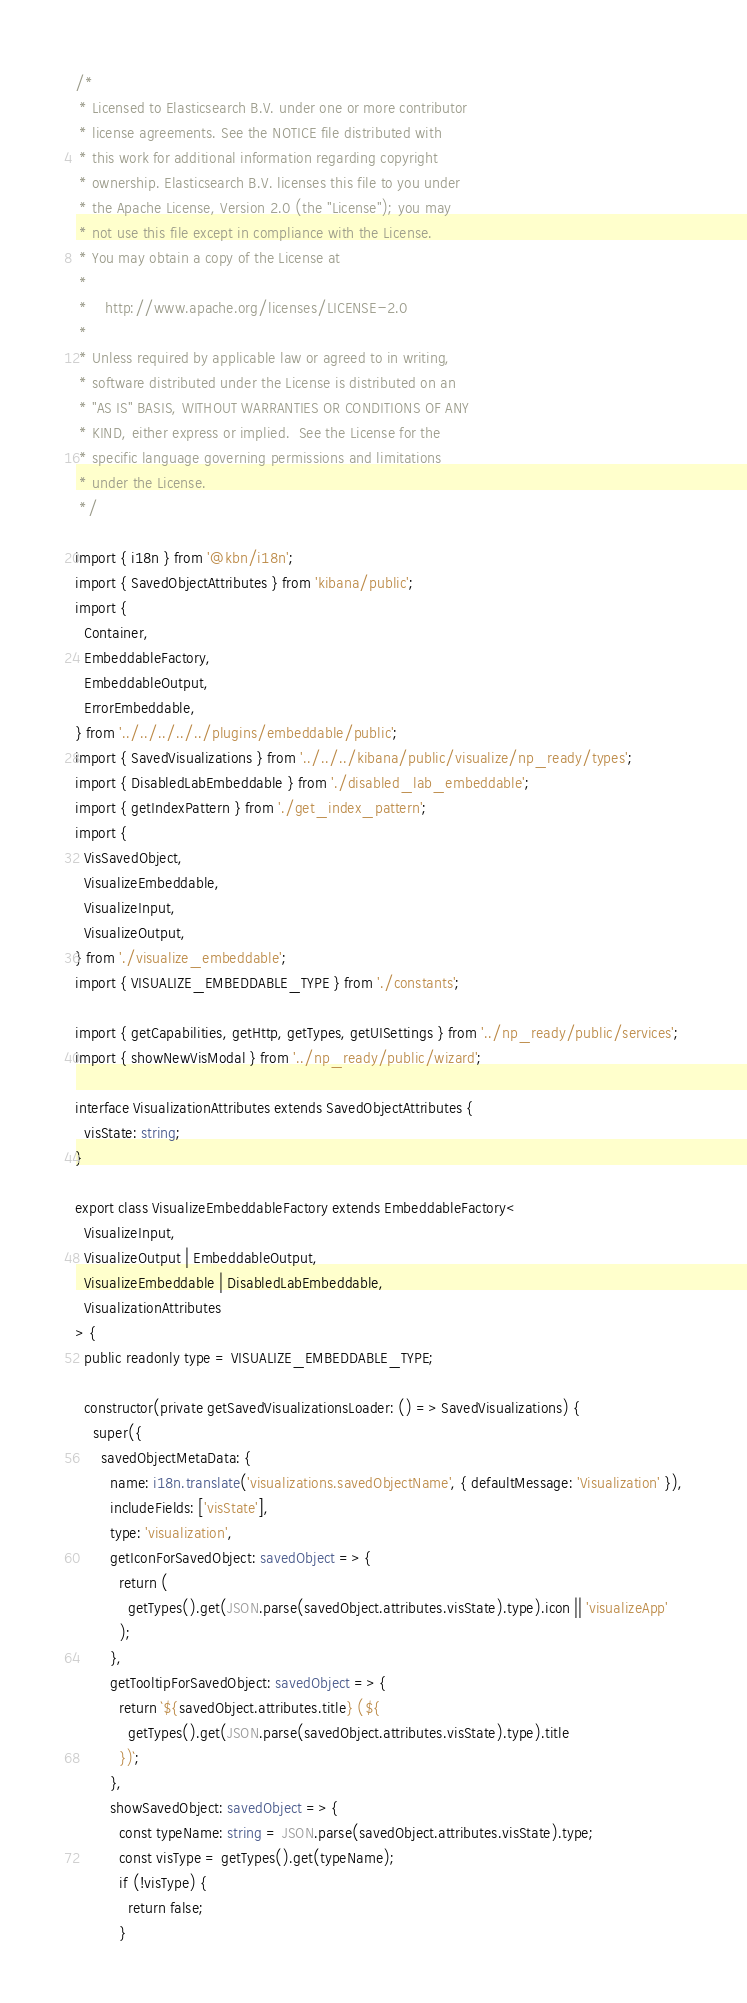<code> <loc_0><loc_0><loc_500><loc_500><_TypeScript_>/*
 * Licensed to Elasticsearch B.V. under one or more contributor
 * license agreements. See the NOTICE file distributed with
 * this work for additional information regarding copyright
 * ownership. Elasticsearch B.V. licenses this file to you under
 * the Apache License, Version 2.0 (the "License"); you may
 * not use this file except in compliance with the License.
 * You may obtain a copy of the License at
 *
 *    http://www.apache.org/licenses/LICENSE-2.0
 *
 * Unless required by applicable law or agreed to in writing,
 * software distributed under the License is distributed on an
 * "AS IS" BASIS, WITHOUT WARRANTIES OR CONDITIONS OF ANY
 * KIND, either express or implied.  See the License for the
 * specific language governing permissions and limitations
 * under the License.
 */

import { i18n } from '@kbn/i18n';
import { SavedObjectAttributes } from 'kibana/public';
import {
  Container,
  EmbeddableFactory,
  EmbeddableOutput,
  ErrorEmbeddable,
} from '../../../../../plugins/embeddable/public';
import { SavedVisualizations } from '../../../kibana/public/visualize/np_ready/types';
import { DisabledLabEmbeddable } from './disabled_lab_embeddable';
import { getIndexPattern } from './get_index_pattern';
import {
  VisSavedObject,
  VisualizeEmbeddable,
  VisualizeInput,
  VisualizeOutput,
} from './visualize_embeddable';
import { VISUALIZE_EMBEDDABLE_TYPE } from './constants';

import { getCapabilities, getHttp, getTypes, getUISettings } from '../np_ready/public/services';
import { showNewVisModal } from '../np_ready/public/wizard';

interface VisualizationAttributes extends SavedObjectAttributes {
  visState: string;
}

export class VisualizeEmbeddableFactory extends EmbeddableFactory<
  VisualizeInput,
  VisualizeOutput | EmbeddableOutput,
  VisualizeEmbeddable | DisabledLabEmbeddable,
  VisualizationAttributes
> {
  public readonly type = VISUALIZE_EMBEDDABLE_TYPE;

  constructor(private getSavedVisualizationsLoader: () => SavedVisualizations) {
    super({
      savedObjectMetaData: {
        name: i18n.translate('visualizations.savedObjectName', { defaultMessage: 'Visualization' }),
        includeFields: ['visState'],
        type: 'visualization',
        getIconForSavedObject: savedObject => {
          return (
            getTypes().get(JSON.parse(savedObject.attributes.visState).type).icon || 'visualizeApp'
          );
        },
        getTooltipForSavedObject: savedObject => {
          return `${savedObject.attributes.title} (${
            getTypes().get(JSON.parse(savedObject.attributes.visState).type).title
          })`;
        },
        showSavedObject: savedObject => {
          const typeName: string = JSON.parse(savedObject.attributes.visState).type;
          const visType = getTypes().get(typeName);
          if (!visType) {
            return false;
          }</code> 